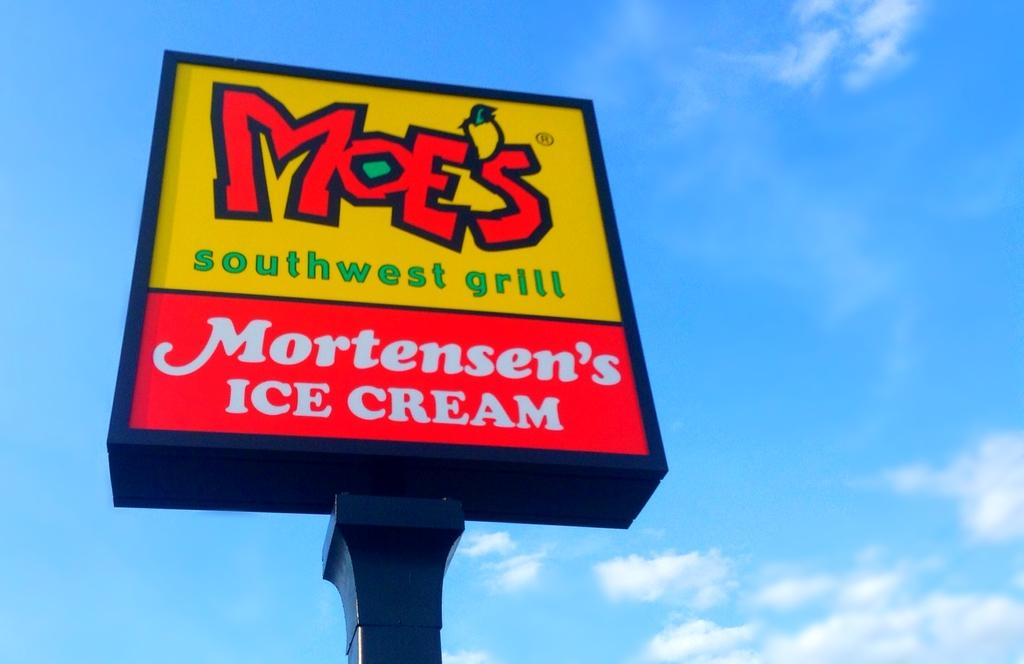<image>
Offer a succinct explanation of the picture presented. a sign for Moe's Southwest Grill and Mortensen's Ice Cream 